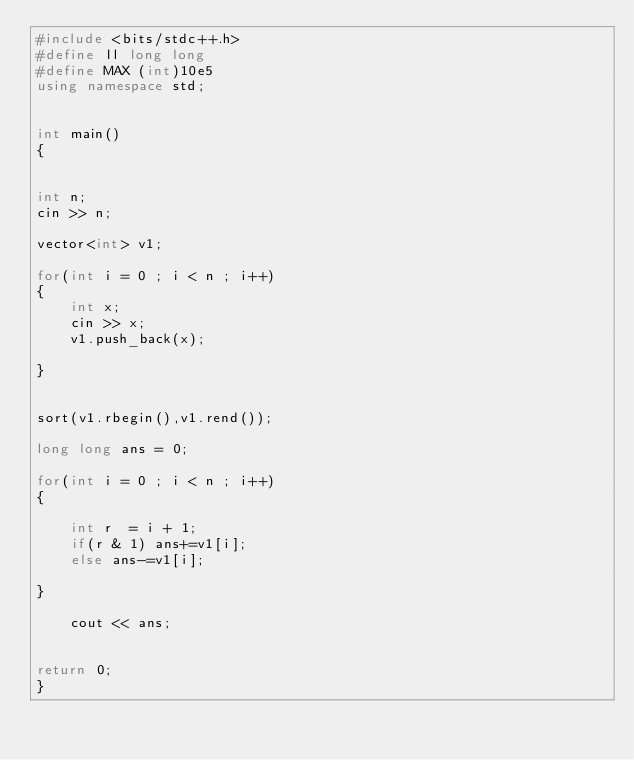<code> <loc_0><loc_0><loc_500><loc_500><_C++_>#include <bits/stdc++.h>
#define ll long long
#define MAX (int)10e5
using namespace std;


int main()
{


int n;
cin >> n;

vector<int> v1;

for(int i = 0 ; i < n ; i++)
{
    int x;
    cin >> x;
    v1.push_back(x);
    
}


sort(v1.rbegin(),v1.rend());

long long ans = 0;

for(int i = 0 ; i < n ; i++)
{
    
    int r  = i + 1;
    if(r & 1) ans+=v1[i];
    else ans-=v1[i];

}
    
    cout << ans;
    

return 0;		
}</code> 